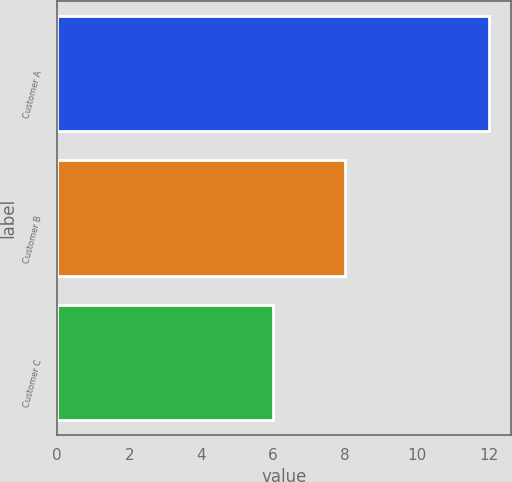Convert chart to OTSL. <chart><loc_0><loc_0><loc_500><loc_500><bar_chart><fcel>Customer A<fcel>Customer B<fcel>Customer C<nl><fcel>12<fcel>8<fcel>6<nl></chart> 